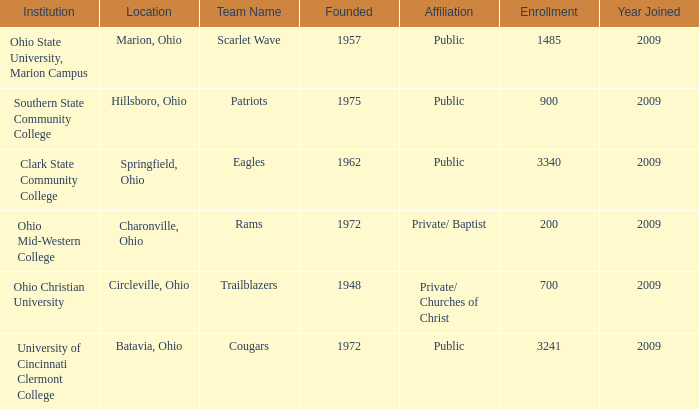What was the location for the team name of patriots? Hillsboro, Ohio. 